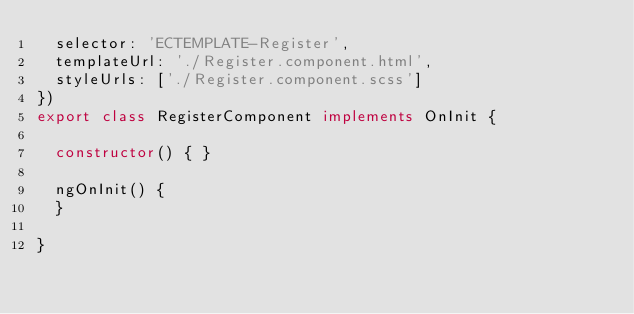<code> <loc_0><loc_0><loc_500><loc_500><_TypeScript_>  selector: 'ECTEMPLATE-Register',
  templateUrl: './Register.component.html',
  styleUrls: ['./Register.component.scss']
})
export class RegisterComponent implements OnInit {

  constructor() { }

  ngOnInit() {
  }

}
</code> 